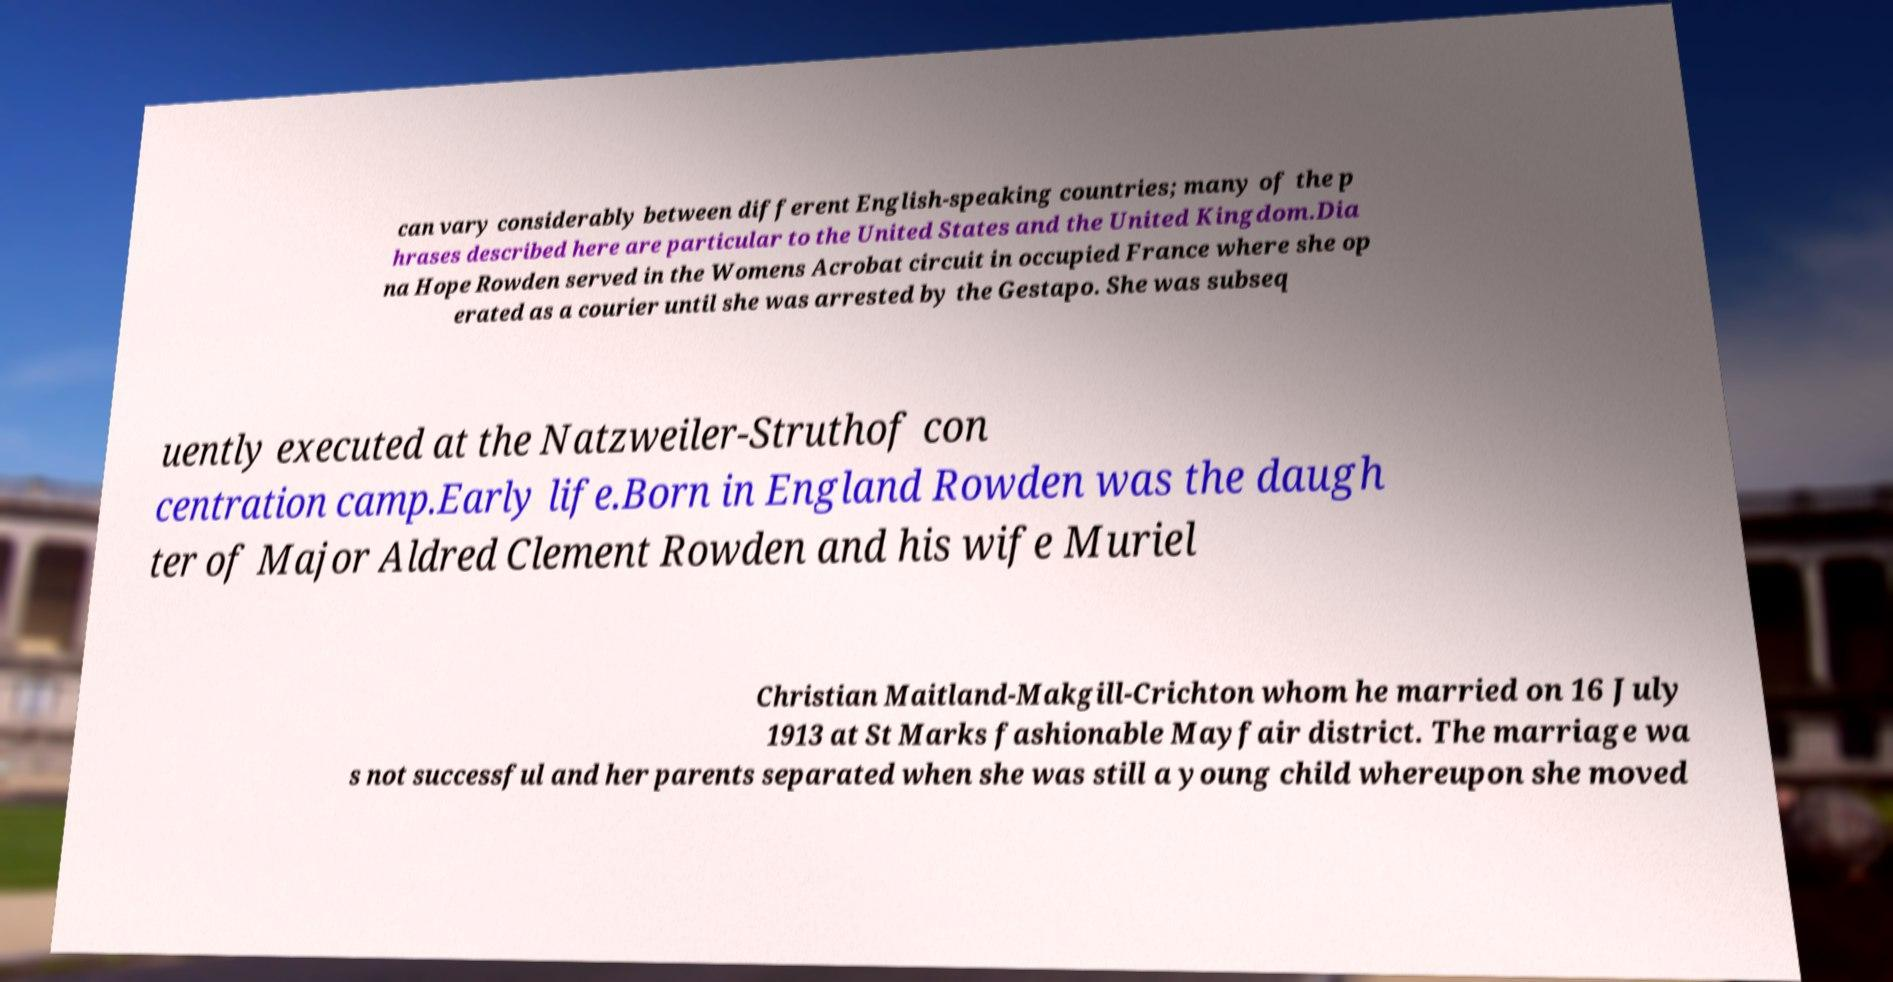What messages or text are displayed in this image? I need them in a readable, typed format. can vary considerably between different English-speaking countries; many of the p hrases described here are particular to the United States and the United Kingdom.Dia na Hope Rowden served in the Womens Acrobat circuit in occupied France where she op erated as a courier until she was arrested by the Gestapo. She was subseq uently executed at the Natzweiler-Struthof con centration camp.Early life.Born in England Rowden was the daugh ter of Major Aldred Clement Rowden and his wife Muriel Christian Maitland-Makgill-Crichton whom he married on 16 July 1913 at St Marks fashionable Mayfair district. The marriage wa s not successful and her parents separated when she was still a young child whereupon she moved 